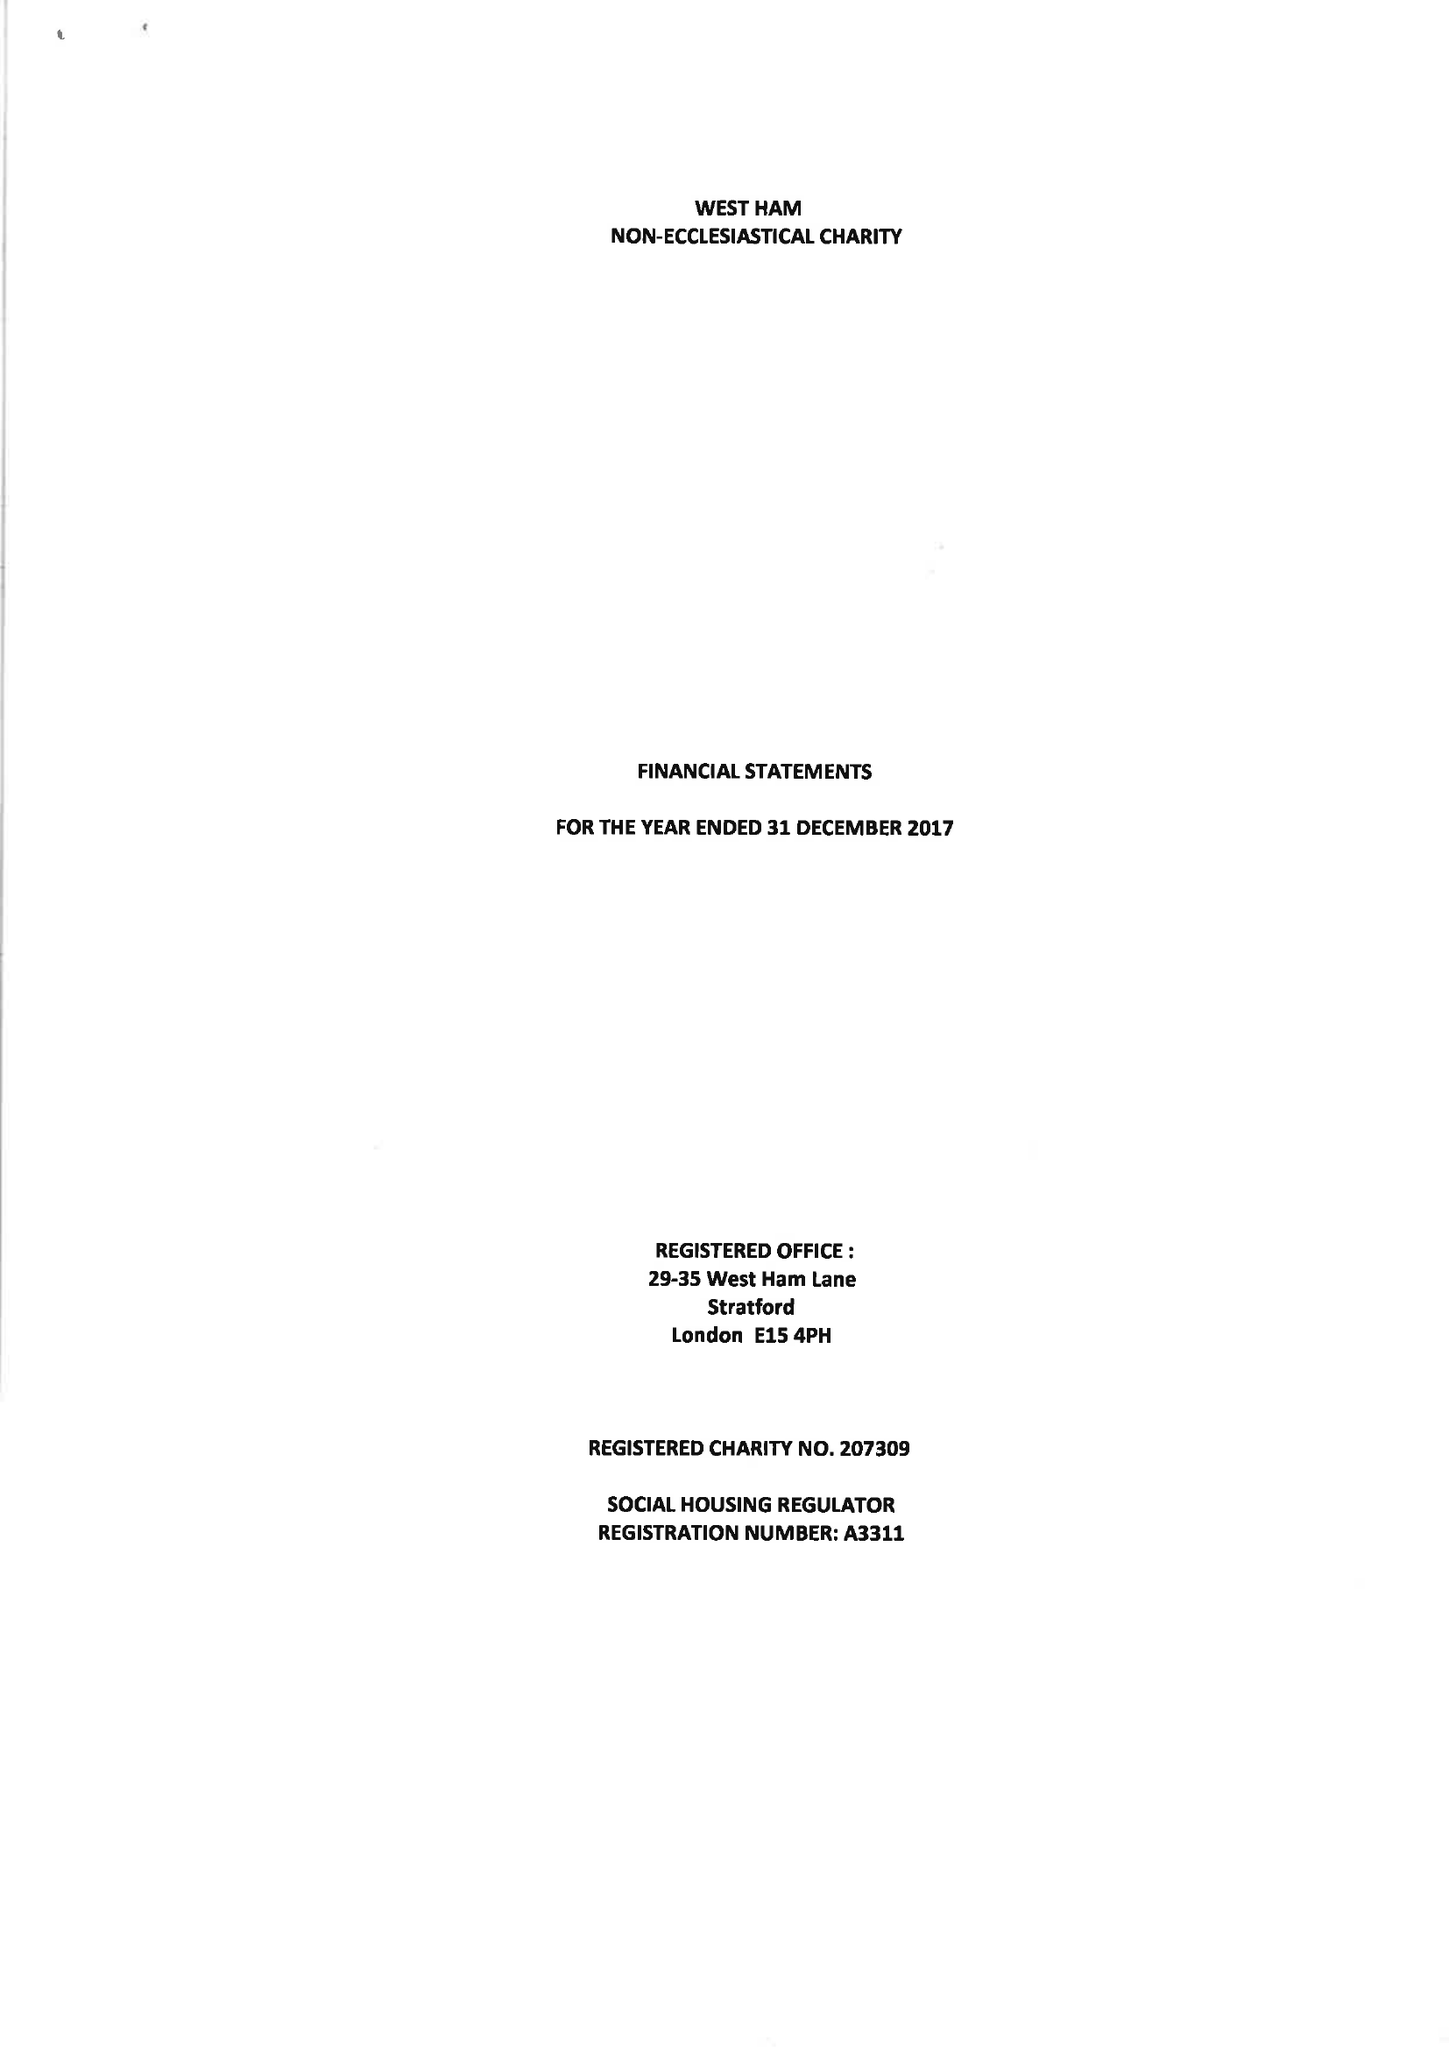What is the value for the report_date?
Answer the question using a single word or phrase. 2017-12-31 